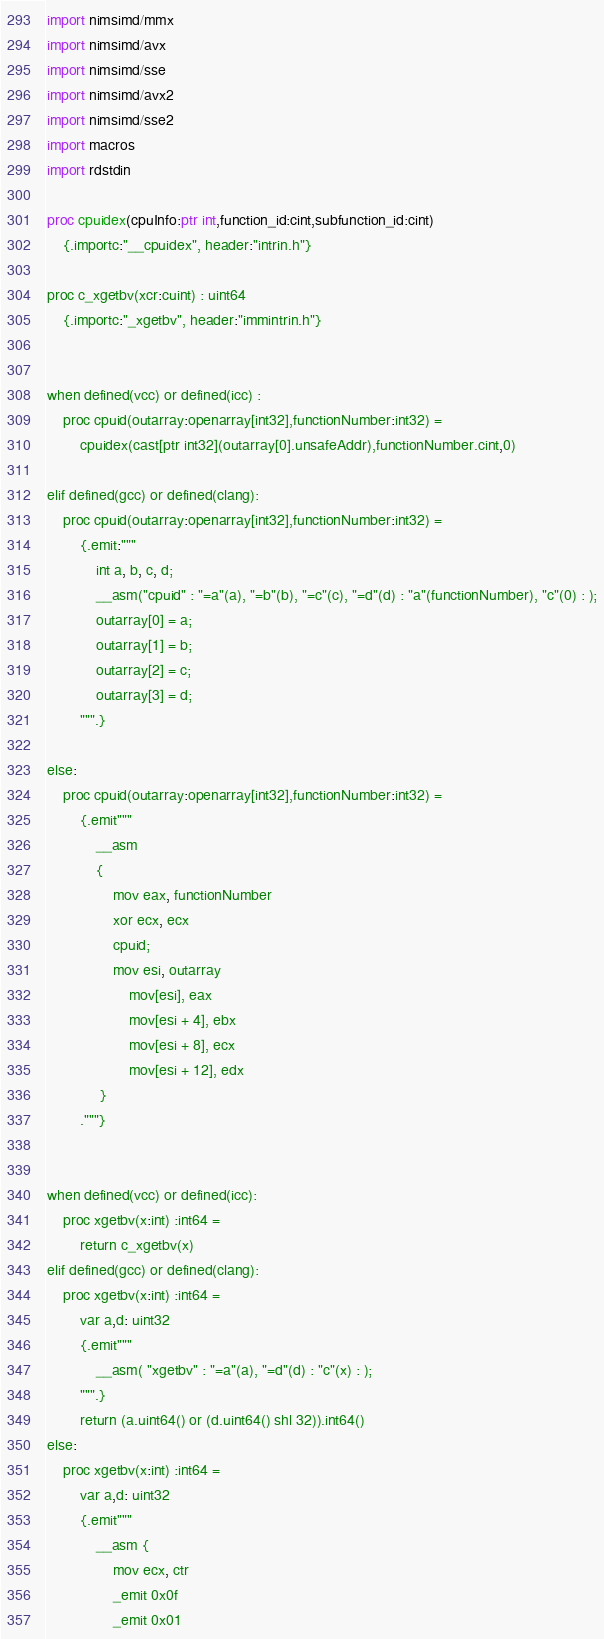Convert code to text. <code><loc_0><loc_0><loc_500><loc_500><_Nim_>import nimsimd/mmx
import nimsimd/avx
import nimsimd/sse
import nimsimd/avx2
import nimsimd/sse2
import macros 
import rdstdin

proc cpuidex(cpuInfo:ptr int,function_id:cint,subfunction_id:cint)
    {.importc:"__cpuidex", header:"intrin.h"}

proc c_xgetbv(xcr:cuint) : uint64
    {.importc:"_xgetbv", header:"immintrin.h"}


when defined(vcc) or defined(icc) :
    proc cpuid(outarray:openarray[int32],functionNumber:int32) =
        cpuidex(cast[ptr int32](outarray[0].unsafeAddr),functionNumber.cint,0)
    
elif defined(gcc) or defined(clang):        
    proc cpuid(outarray:openarray[int32],functionNumber:int32) =
        {.emit:"""
            int a, b, c, d;
            __asm("cpuid" : "=a"(a), "=b"(b), "=c"(c), "=d"(d) : "a"(functionNumber), "c"(0) : );
            outarray[0] = a;
            outarray[1] = b;
            outarray[2] = c;
            outarray[3] = d;
        """.}    

else:     
    proc cpuid(outarray:openarray[int32],functionNumber:int32) =
        {.emit"""
            __asm
            {
                mov eax, functionNumber
                xor ecx, ecx
                cpuid;
                mov esi, outarray
                    mov[esi], eax
                    mov[esi + 4], ebx
                    mov[esi + 8], ecx
                    mov[esi + 12], edx
             }
        ."""}


when defined(vcc) or defined(icc):
    proc xgetbv(x:int) :int64 =
        return c_xgetbv(x)
elif defined(gcc) or defined(clang):
    proc xgetbv(x:int) :int64 =
        var a,d: uint32
        {.emit"""            
            __asm( "xgetbv" : "=a"(a), "=d"(d) : "c"(x) : );           
        """.}
        return (a.uint64() or (d.uint64() shl 32)).int64()
else:
    proc xgetbv(x:int) :int64 =
        var a,d: uint32
        {.emit"""            
            __asm {
                mov ecx, ctr
                _emit 0x0f
                _emit 0x01</code> 